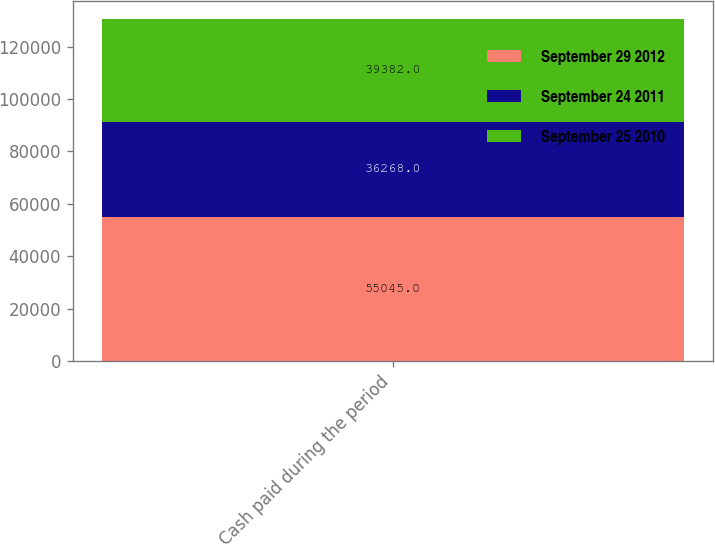Convert chart. <chart><loc_0><loc_0><loc_500><loc_500><stacked_bar_chart><ecel><fcel>Cash paid during the period<nl><fcel>September 29 2012<fcel>55045<nl><fcel>September 24 2011<fcel>36268<nl><fcel>September 25 2010<fcel>39382<nl></chart> 